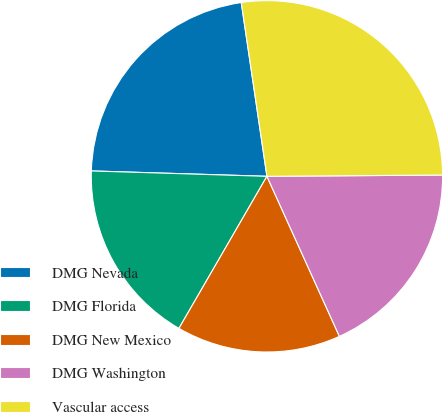<chart> <loc_0><loc_0><loc_500><loc_500><pie_chart><fcel>DMG Nevada<fcel>DMG Florida<fcel>DMG New Mexico<fcel>DMG Washington<fcel>Vascular access<nl><fcel>22.18%<fcel>17.14%<fcel>15.12%<fcel>18.35%<fcel>27.22%<nl></chart> 